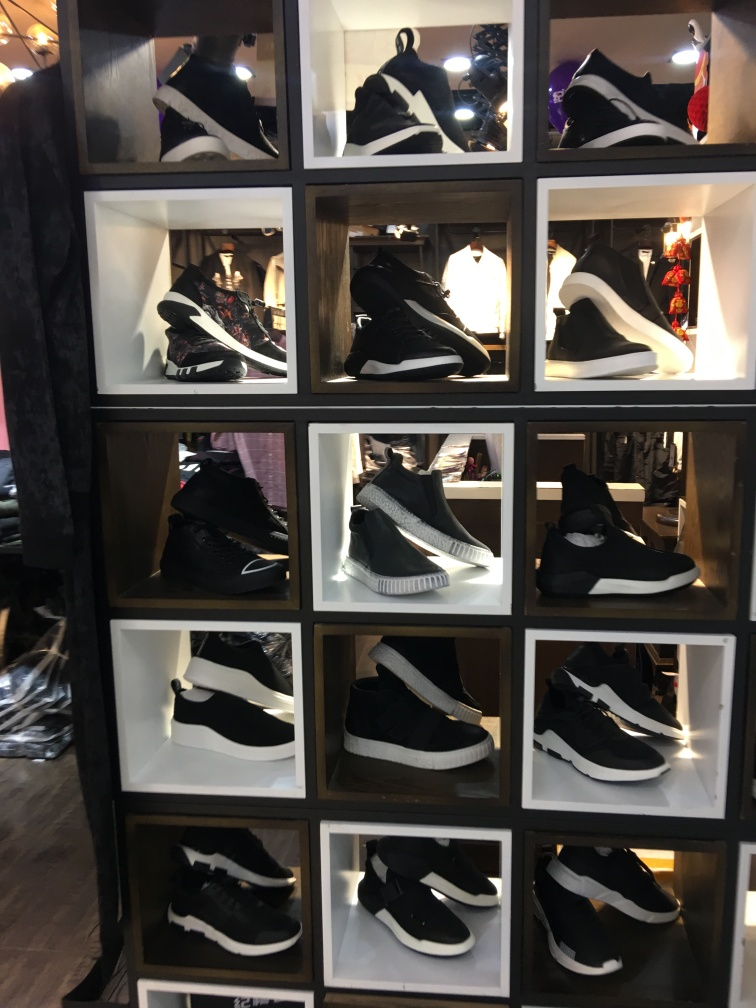Are there any quality issues with this image? While the image does contain a few areas of glare and reflections which could be distracting, it is overall a clear representation of a variety of black and white sneakers displayed in a grid arrangement, presumably in a store. The lighting is adequate to discern the different styles of the shoes, though the angle and reflections may slightly obscure finer design details. 